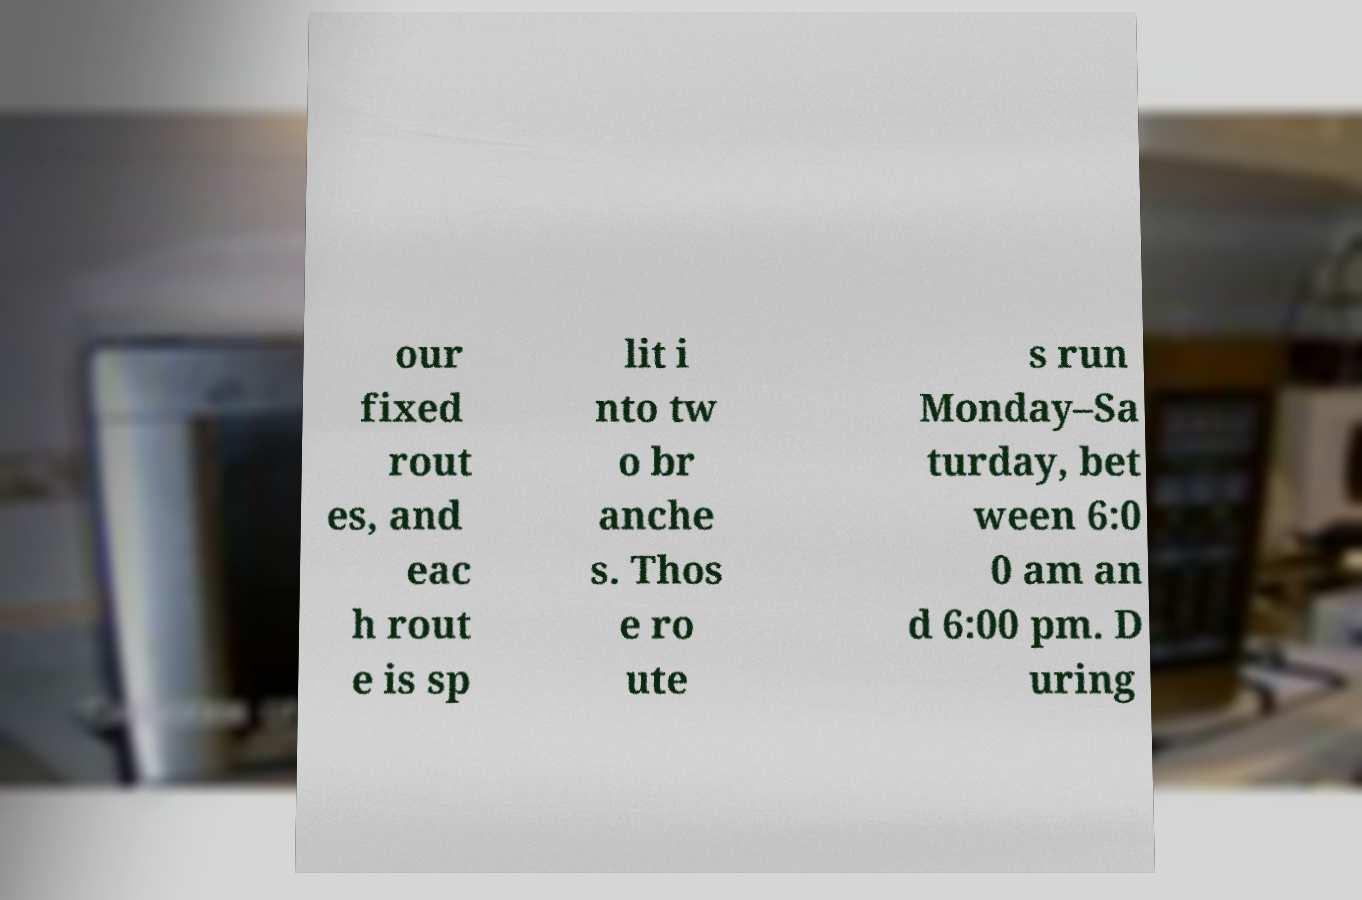For documentation purposes, I need the text within this image transcribed. Could you provide that? our fixed rout es, and eac h rout e is sp lit i nto tw o br anche s. Thos e ro ute s run Monday–Sa turday, bet ween 6:0 0 am an d 6:00 pm. D uring 